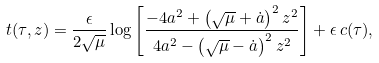<formula> <loc_0><loc_0><loc_500><loc_500>t ( \tau , z ) = \frac { \epsilon } { 2 \sqrt { \mu } } \log \left [ \frac { - 4 a ^ { 2 } + \left ( \sqrt { \mu } + \dot { a } \right ) ^ { 2 } z ^ { 2 } } { 4 a ^ { 2 } - \left ( \sqrt { \mu } - \dot { a } \right ) ^ { 2 } z ^ { 2 } } \right ] + \epsilon \, c ( \tau ) ,</formula> 